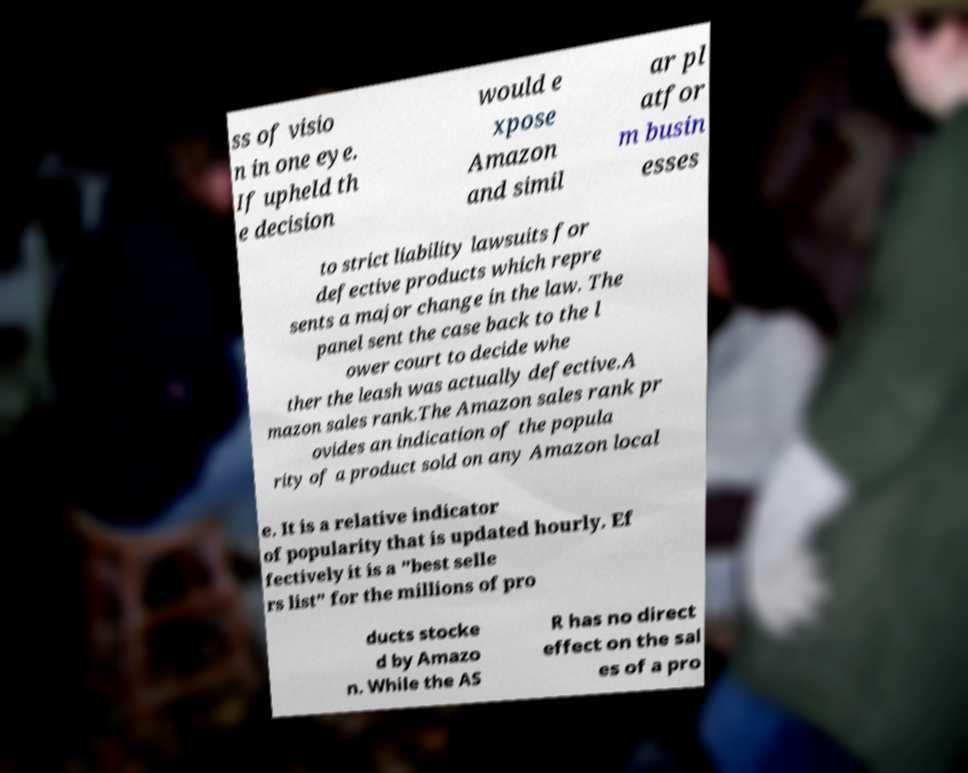What messages or text are displayed in this image? I need them in a readable, typed format. ss of visio n in one eye. If upheld th e decision would e xpose Amazon and simil ar pl atfor m busin esses to strict liability lawsuits for defective products which repre sents a major change in the law. The panel sent the case back to the l ower court to decide whe ther the leash was actually defective.A mazon sales rank.The Amazon sales rank pr ovides an indication of the popula rity of a product sold on any Amazon local e. It is a relative indicator of popularity that is updated hourly. Ef fectively it is a "best selle rs list" for the millions of pro ducts stocke d by Amazo n. While the AS R has no direct effect on the sal es of a pro 